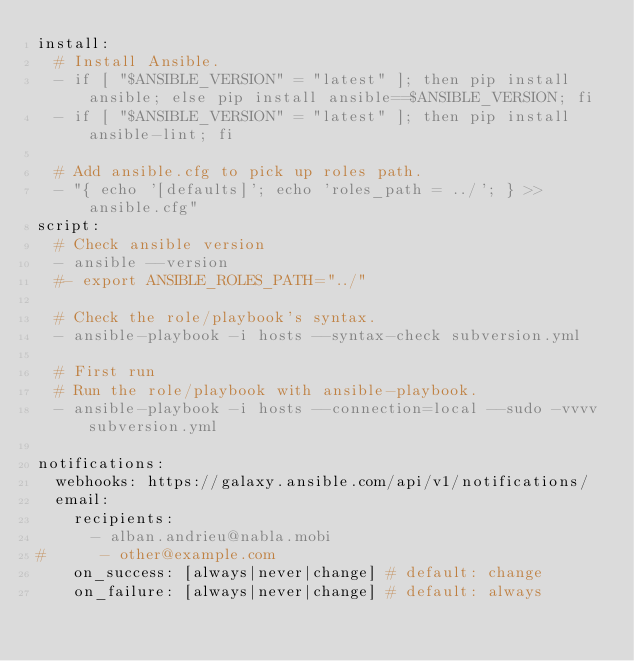Convert code to text. <code><loc_0><loc_0><loc_500><loc_500><_YAML_>install:
  # Install Ansible.
  - if [ "$ANSIBLE_VERSION" = "latest" ]; then pip install ansible; else pip install ansible==$ANSIBLE_VERSION; fi
  - if [ "$ANSIBLE_VERSION" = "latest" ]; then pip install ansible-lint; fi

  # Add ansible.cfg to pick up roles path.
  - "{ echo '[defaults]'; echo 'roles_path = ../'; } >> ansible.cfg"
script:
  # Check ansible version
  - ansible --version
  #- export ANSIBLE_ROLES_PATH="../"

  # Check the role/playbook's syntax.
  - ansible-playbook -i hosts --syntax-check subversion.yml
  
  # First run
  # Run the role/playbook with ansible-playbook.  
  - ansible-playbook -i hosts --connection=local --sudo -vvvv subversion.yml

notifications:
  webhooks: https://galaxy.ansible.com/api/v1/notifications/
  email:
    recipients:
      - alban.andrieu@nabla.mobi
#      - other@example.com
    on_success: [always|never|change] # default: change
    on_failure: [always|never|change] # default: always
</code> 